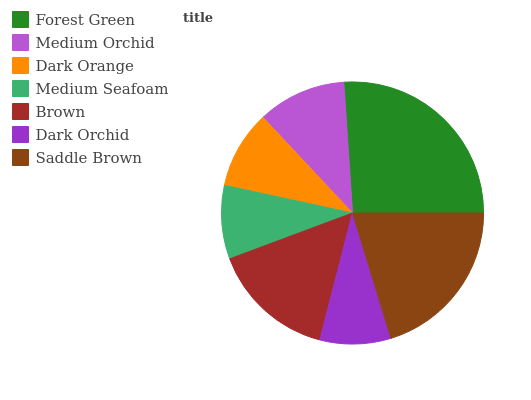Is Dark Orchid the minimum?
Answer yes or no. Yes. Is Forest Green the maximum?
Answer yes or no. Yes. Is Medium Orchid the minimum?
Answer yes or no. No. Is Medium Orchid the maximum?
Answer yes or no. No. Is Forest Green greater than Medium Orchid?
Answer yes or no. Yes. Is Medium Orchid less than Forest Green?
Answer yes or no. Yes. Is Medium Orchid greater than Forest Green?
Answer yes or no. No. Is Forest Green less than Medium Orchid?
Answer yes or no. No. Is Medium Orchid the high median?
Answer yes or no. Yes. Is Medium Orchid the low median?
Answer yes or no. Yes. Is Saddle Brown the high median?
Answer yes or no. No. Is Dark Orange the low median?
Answer yes or no. No. 